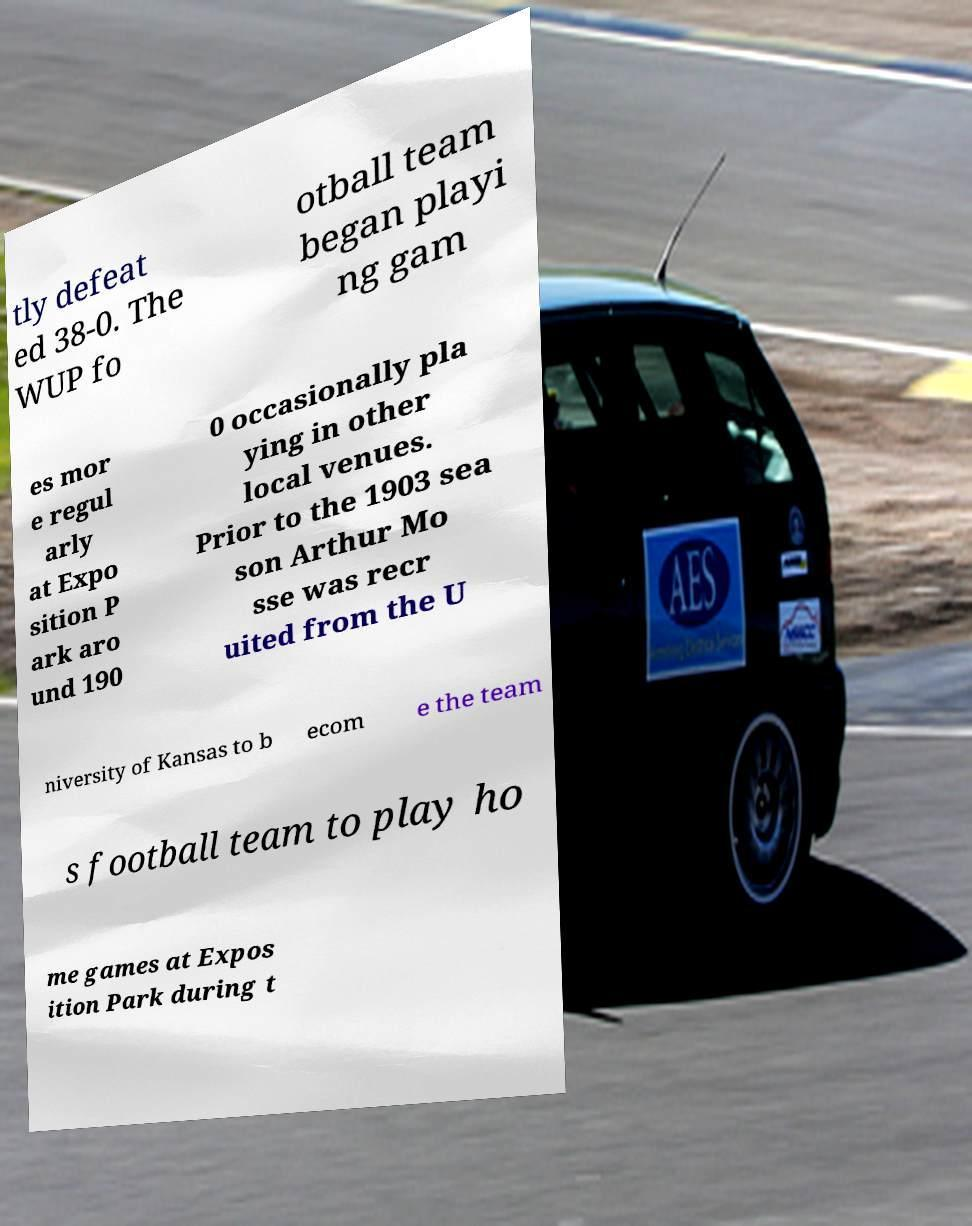There's text embedded in this image that I need extracted. Can you transcribe it verbatim? tly defeat ed 38-0. The WUP fo otball team began playi ng gam es mor e regul arly at Expo sition P ark aro und 190 0 occasionally pla ying in other local venues. Prior to the 1903 sea son Arthur Mo sse was recr uited from the U niversity of Kansas to b ecom e the team s football team to play ho me games at Expos ition Park during t 